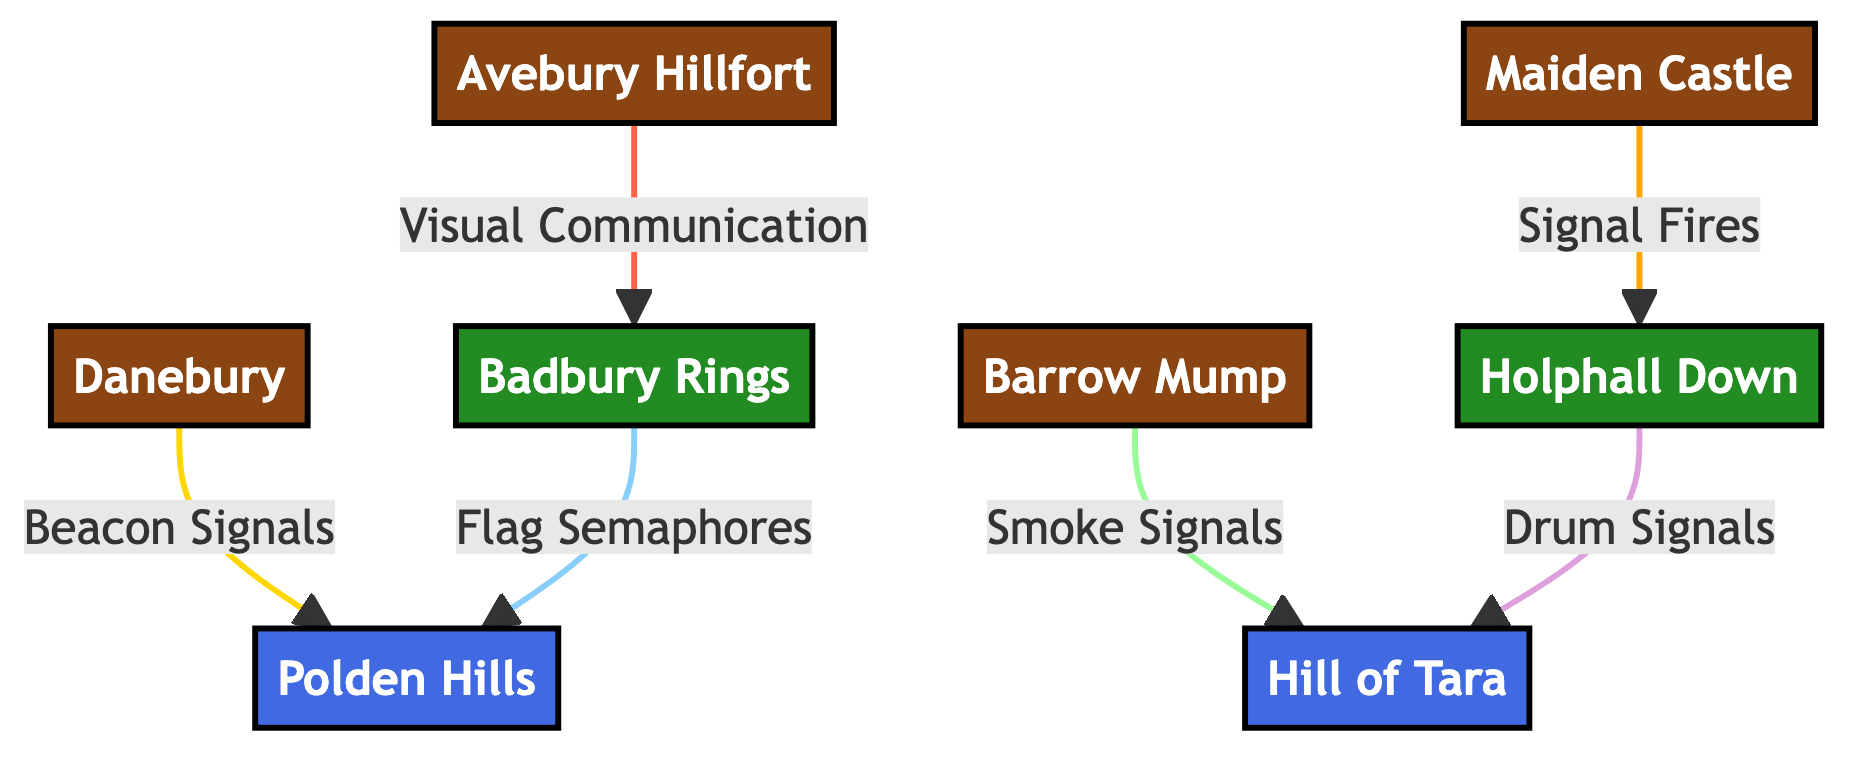What is the total number of nodes in the diagram? The diagram lists eight different nodes: Avebury Hillfort, Maiden Castle, Danebury, Barrow Mump, Badbury Rings, Holphall Down, Polden Hills Signal Station, and Hill of Tara Signal Station. Therefore, the total count of nodes is eight.
Answer: 8 Which hillfort is connected to Badbury Rings by Visual Communication? According to the diagram, Avebury Hillfort is connected to Badbury Rings through a relationship defined as Visual Communication. This can be seen by identifying the edge labeled with this type of connection.
Answer: Avebury Hillfort What type of signal is used between Maiden Castle and Holphall Down? The edge connecting Maiden Castle to Holphall Down is labeled as Signal Fires. This relationship can be confirmed by looking at the specific connection between these two nodes in the diagram.
Answer: Signal Fires How many types of communication relations are represented in the diagram? Observing the edges in the diagram, there are five distinct types of communication relations: Visual Communication, Signal Fires, Beacon Signals, Smoke Signals, and Flag Semaphores, plus Drum Signals. Thus, the total is six.
Answer: 6 Which signal station does Barrow Mump communicate with and what is the type of signal? Barrow Mump communicates with Hill of Tara Signal Station using Smoke Signals, as indicated by the respective edge in the diagram that connects these two nodes and specifies this relationship.
Answer: Hill of Tara Signal Station, Smoke Signals What is the initiating hillfort for Beacon Signals? The diagram shows that Danebury is the hillfort that initiates the relationship of Beacon Signals, as can be verified by tracing the direct edge from Danebury to Polden Hills Signal Station with this label.
Answer: Danebury Which watchtower connects with Polden Hills Signal Station, and what is its communication type? Badbury Rings is the watchtower that connects with Polden Hills Signal Station. The type of communication used here is Flag Semaphores, noted on the connecting edge.
Answer: Badbury Rings, Flag Semaphores Which two fortifications use Drum Signals? Upon examining the diagram, it is evident that only Holphall Down, which is a watchtower, uses Drum Signals in connection with Hill of Tara Signal Station, showcasing a singular relationship in this context.
Answer: Holphall Down, Hill of Tara Signal Station 